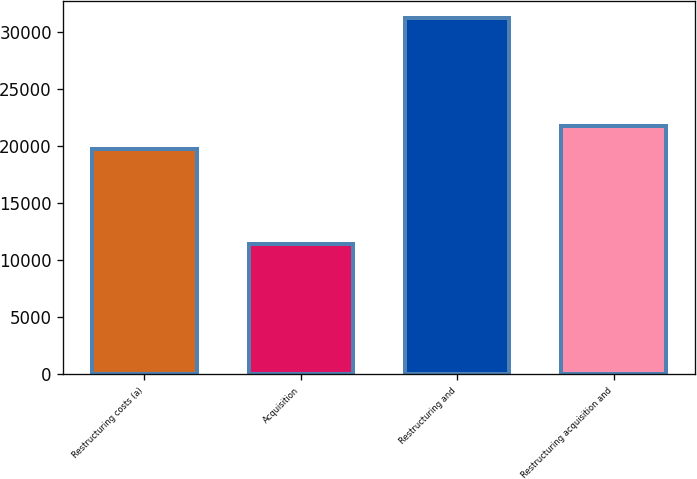<chart> <loc_0><loc_0><loc_500><loc_500><bar_chart><fcel>Restructuring costs (a)<fcel>Acquisition<fcel>Restructuring and<fcel>Restructuring acquisition and<nl><fcel>19795<fcel>11426<fcel>31221<fcel>21774.5<nl></chart> 